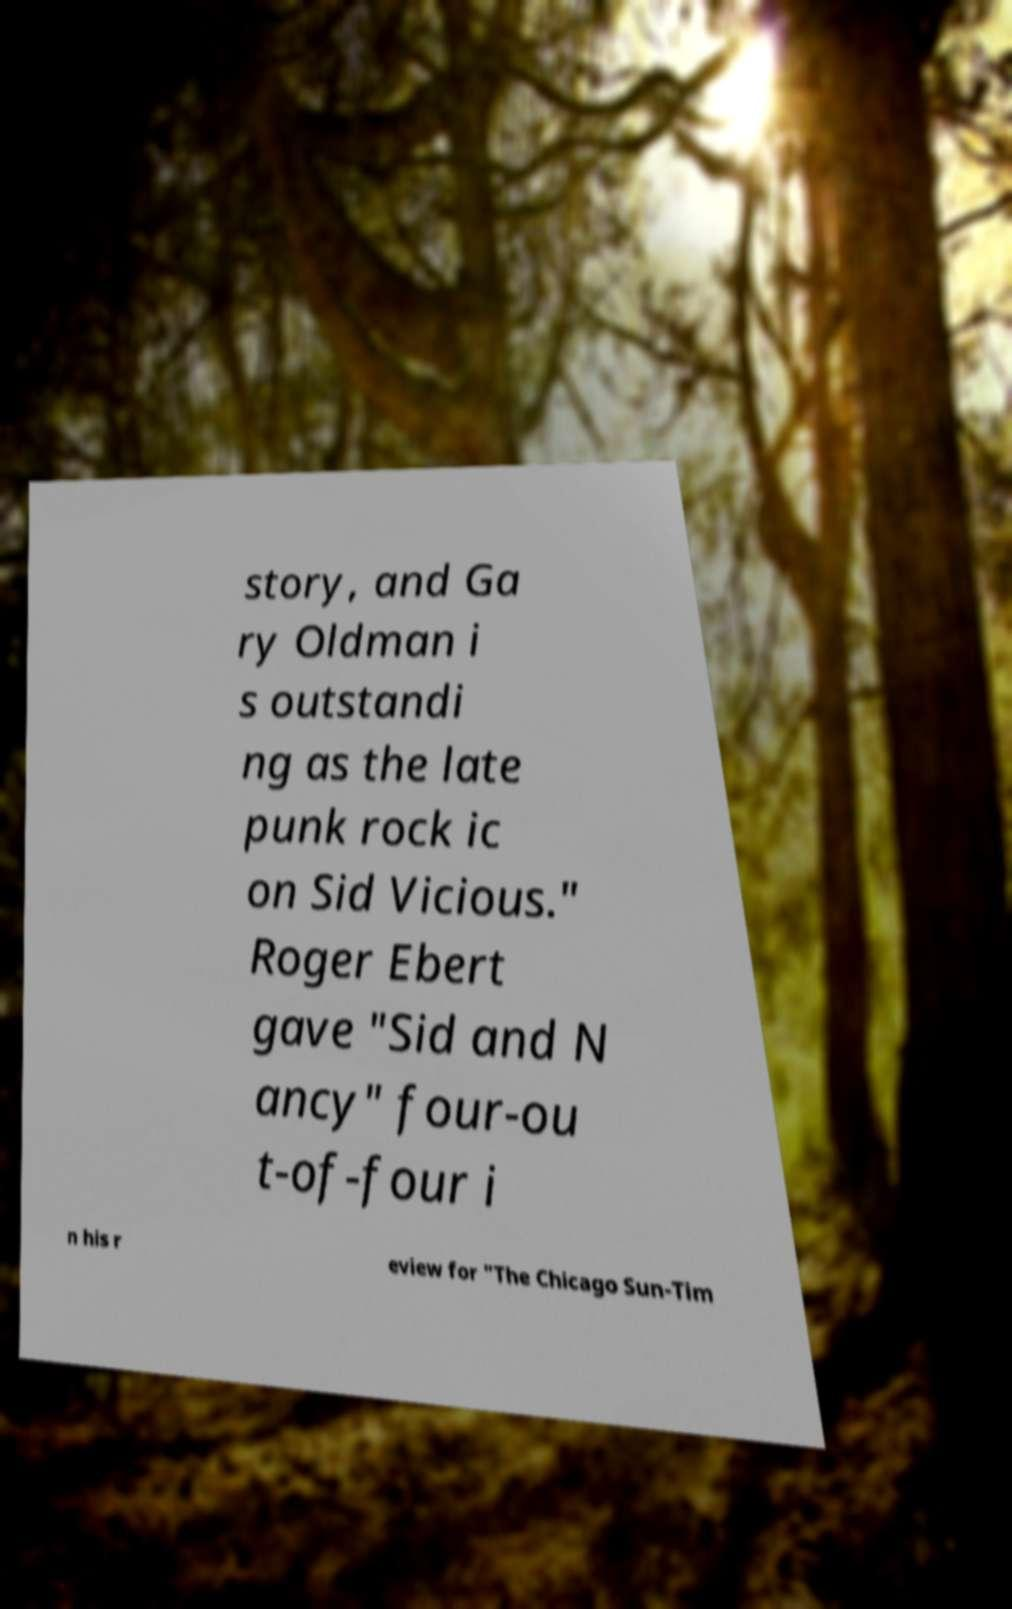Can you accurately transcribe the text from the provided image for me? story, and Ga ry Oldman i s outstandi ng as the late punk rock ic on Sid Vicious." Roger Ebert gave "Sid and N ancy" four-ou t-of-four i n his r eview for "The Chicago Sun-Tim 